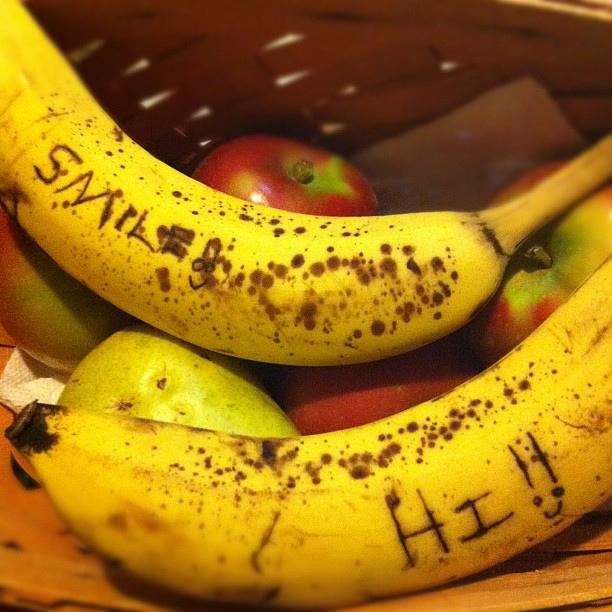What is on the fruit? Please explain your reasoning. writing. Someone scratched letters into the banana peel and as it browns so did the letters. 